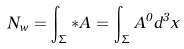Convert formula to latex. <formula><loc_0><loc_0><loc_500><loc_500>N _ { w } = \int _ { \Sigma } { * A } = \int _ { \Sigma } { A ^ { 0 } d ^ { 3 } x }</formula> 